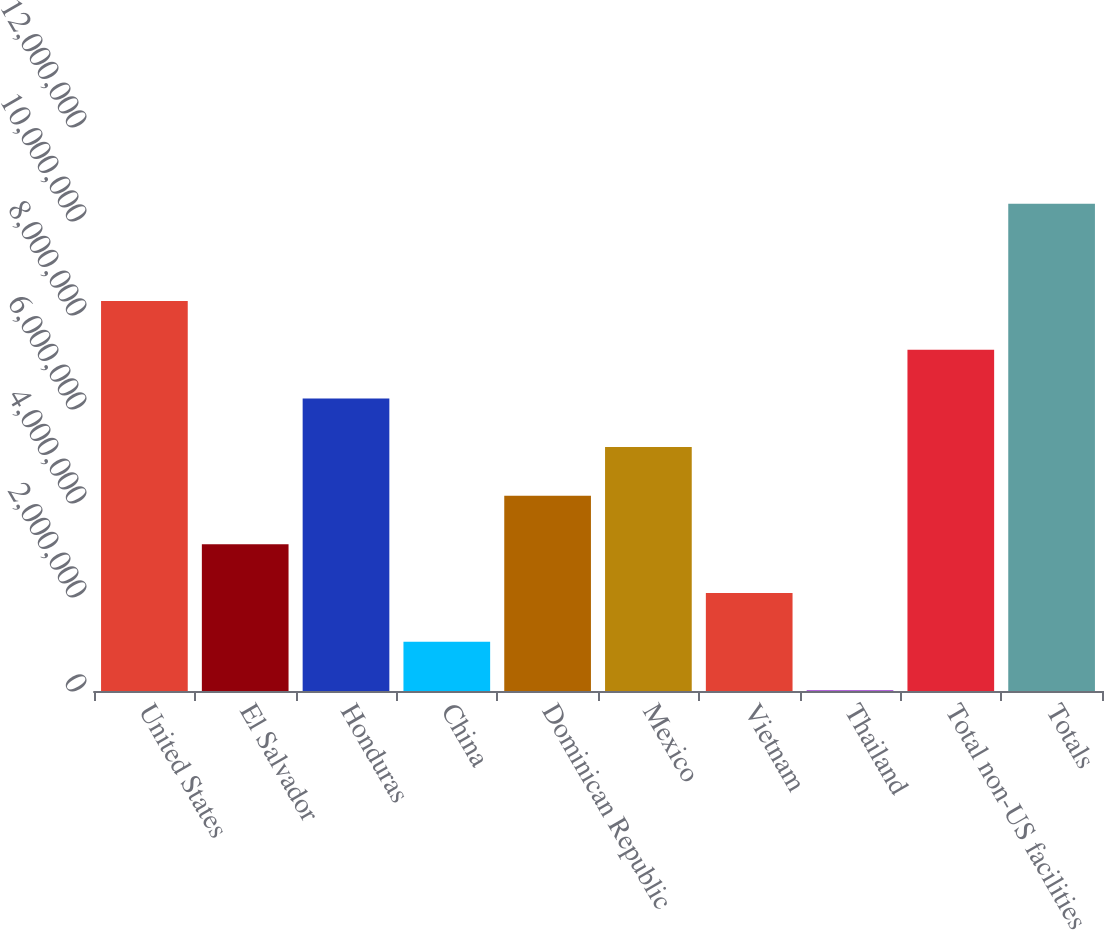Convert chart. <chart><loc_0><loc_0><loc_500><loc_500><bar_chart><fcel>United States<fcel>El Salvador<fcel>Honduras<fcel>China<fcel>Dominican Republic<fcel>Mexico<fcel>Vietnam<fcel>Thailand<fcel>Total non-US facilities<fcel>Totals<nl><fcel>8.29668e+06<fcel>3.12009e+06<fcel>6.22605e+06<fcel>1.04946e+06<fcel>4.15541e+06<fcel>5.19073e+06<fcel>2.08478e+06<fcel>14142<fcel>7.26136e+06<fcel>1.03673e+07<nl></chart> 